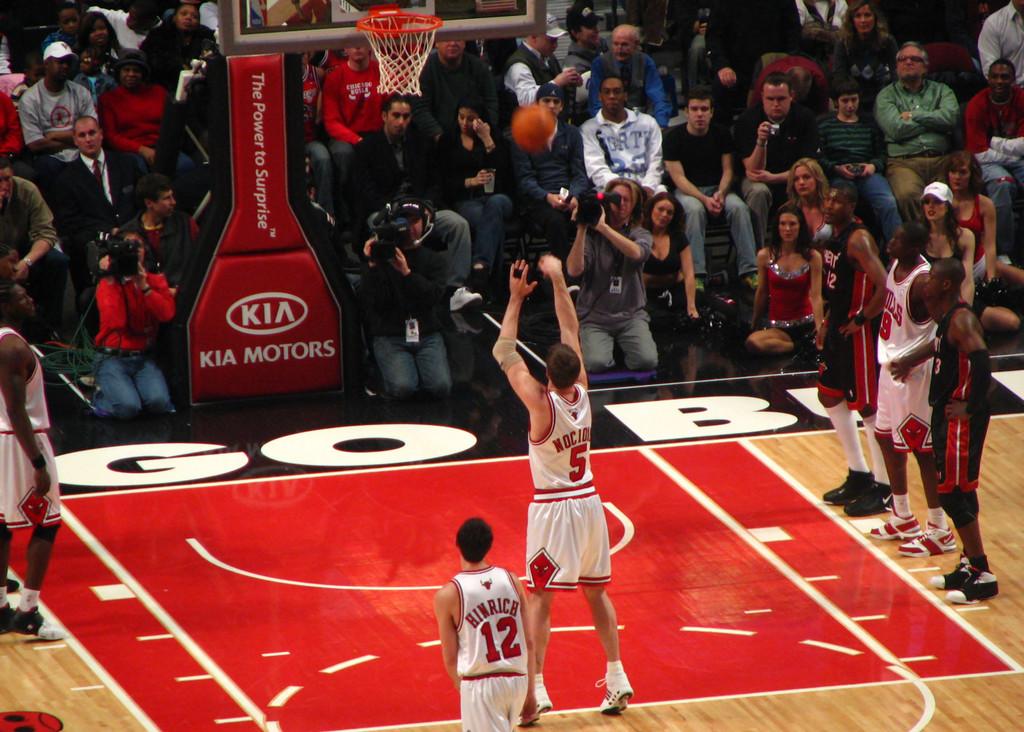What is the name of the player who wears #12?
Your answer should be compact. Hinrich. 